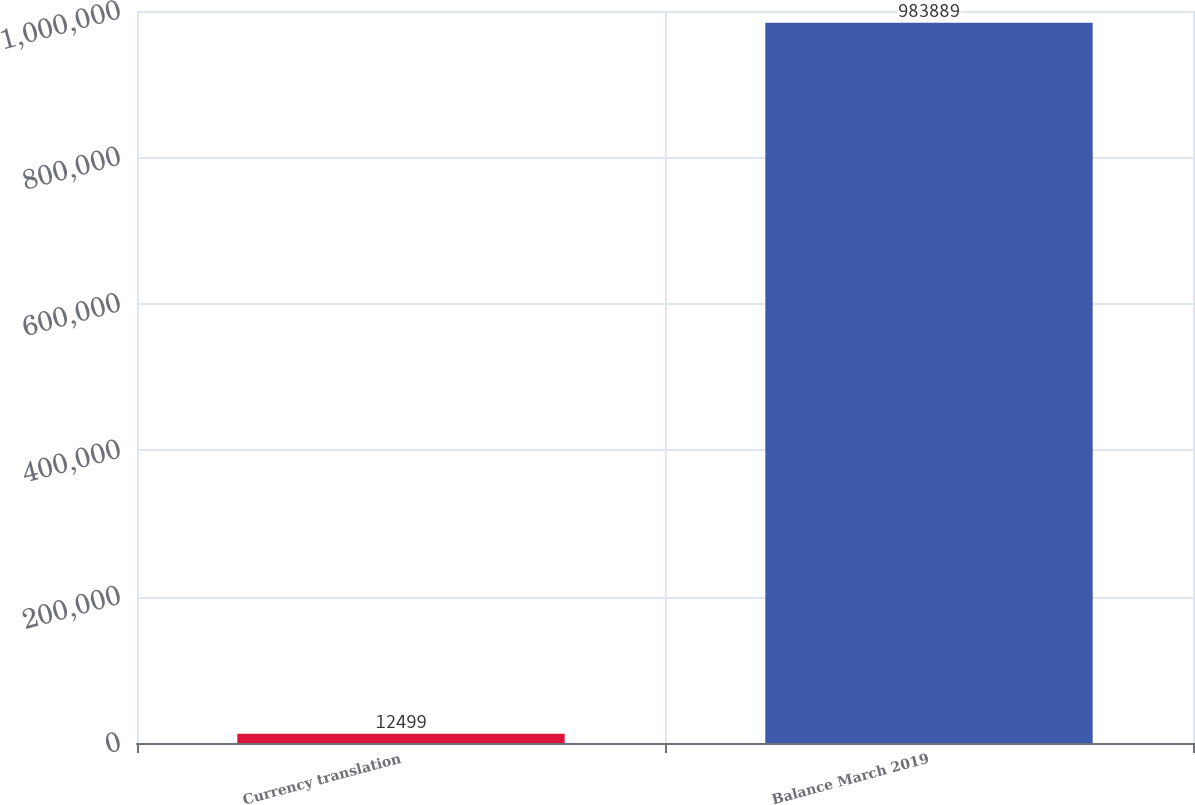<chart> <loc_0><loc_0><loc_500><loc_500><bar_chart><fcel>Currency translation<fcel>Balance March 2019<nl><fcel>12499<fcel>983889<nl></chart> 